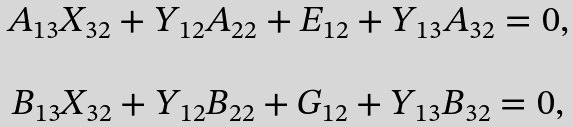<formula> <loc_0><loc_0><loc_500><loc_500>\begin{array} { c } A _ { 1 3 } X _ { 3 2 } + Y _ { 1 2 } A _ { 2 2 } + E _ { 1 2 } + Y _ { 1 3 } A _ { 3 2 } = 0 , \\ \\ B _ { 1 3 } X _ { 3 2 } + Y _ { 1 2 } B _ { 2 2 } + G _ { 1 2 } + Y _ { 1 3 } B _ { 3 2 } = 0 , \end{array}</formula> 